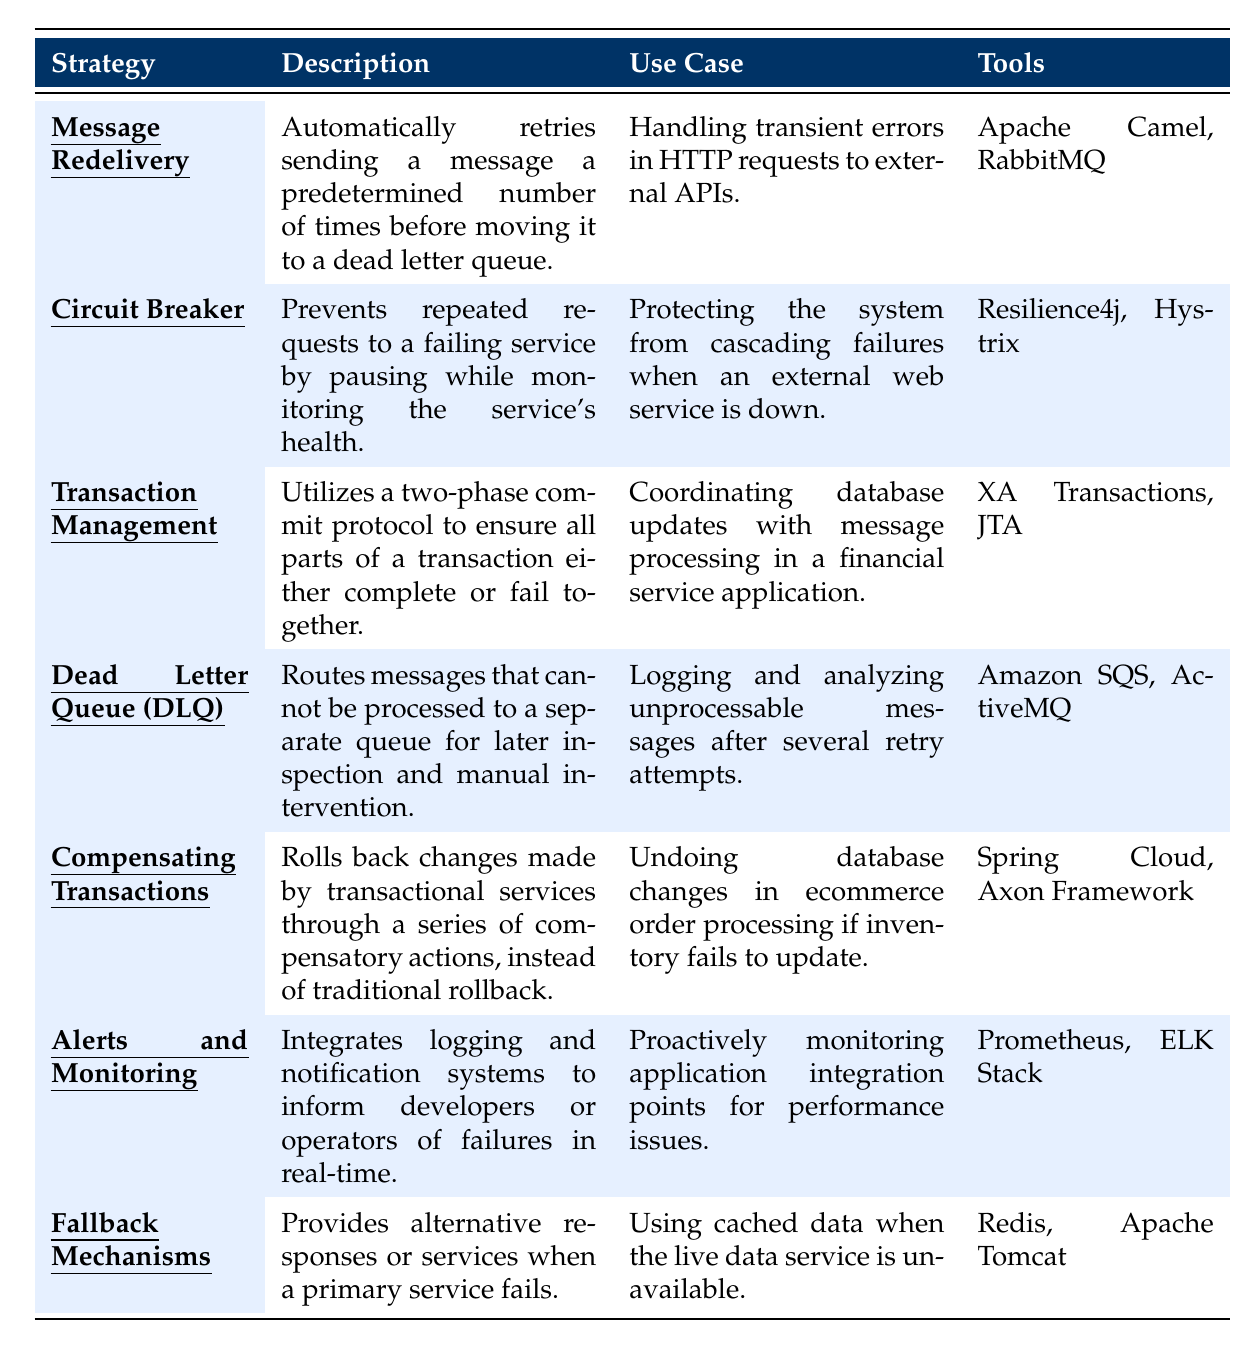What is the strategy used for handling transient errors in HTTP requests to external APIs? The table lists several strategies. Looking under the "Use Case" column, the strategy for handling transient errors in HTTP requests to external APIs is "Message Redelivery."
Answer: Message Redelivery Which tools are associated with the "Dead Letter Queue (DLQ)" strategy? In the table, the "Tools" column corresponding to the "Dead Letter Queue (DLQ)" strategy lists "Amazon SQS" and "ActiveMQ" as associated tools.
Answer: Amazon SQS, ActiveMQ Is "Fallback Mechanisms" used for providing alternative responses when a primary service fails? By checking the "Strategy" and its "Description," "Fallback Mechanisms" is indeed meant to provide alternative responses or services when a primary service fails.
Answer: Yes What is the primary tool listed for the "Circuit Breaker" strategy? Looking at the "Tools" column for the "Circuit Breaker" strategy, the primary tool listed is "Resilience4j."
Answer: Resilience4j Which strategy involves a two-phase commit protocol? According to the table, the strategy that utilizes a two-phase commit protocol is "Transaction Management."
Answer: Transaction Management How many strategies listed involve monitoring or alerting systems? The table includes two strategies related to monitoring or alerting: "Alerts and Monitoring" and "Circuit Breaker." Thus, there are a total of 2 strategies.
Answer: 2 What is the common goal of the "Compensating Transactions" strategy? The "Compensating Transactions" strategy aims to roll back changes made by transactional services through compensatory actions instead of traditional rollback.
Answer: Roll back changes using compensatory actions Which strategies are used to handle errors that occur due to external web service failures? The table indicates that "Circuit Breaker" is specifically designed to protect against cascading failures when an external web service is down. Additionally, "Fallback Mechanisms" is involved as it provides alternative responses when the primary service fails. Thus, both strategies handle such errors.
Answer: Circuit Breaker, Fallback Mechanisms What would you do if a message cannot be processed after several attempts? Referring to the "Dead Letter Queue (DLQ)" strategy, it specifies that messages that cannot be processed should be routed to a separate queue for later inspection and manual intervention.
Answer: Route to a Dead Letter Queue If a financial service application needs to ensure all parts of a transaction succeed or fail together, which strategy should be implemented? The "Transaction Management" strategy is highlighted in the table as it ensures all parts of a transaction either complete or fail together through a two-phase commit protocol.
Answer: Transaction Management 